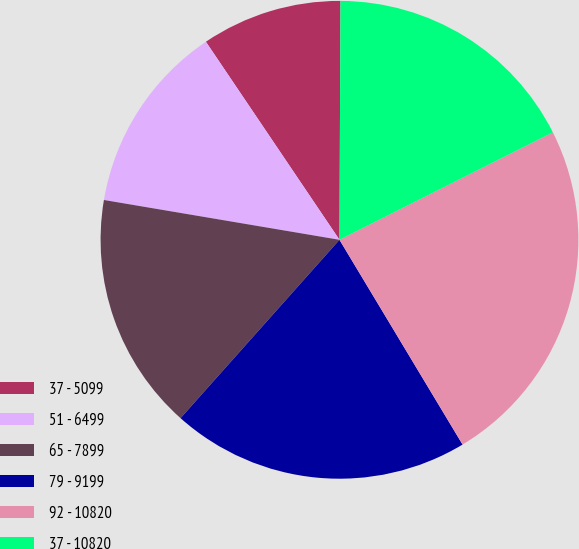Convert chart to OTSL. <chart><loc_0><loc_0><loc_500><loc_500><pie_chart><fcel>37 - 5099<fcel>51 - 6499<fcel>65 - 7899<fcel>79 - 9199<fcel>92 - 10820<fcel>37 - 10820<nl><fcel>9.51%<fcel>12.89%<fcel>16.08%<fcel>20.2%<fcel>23.81%<fcel>17.51%<nl></chart> 